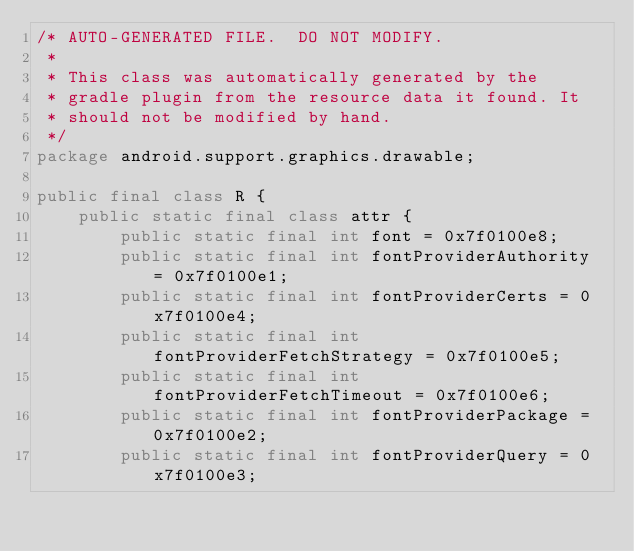<code> <loc_0><loc_0><loc_500><loc_500><_Java_>/* AUTO-GENERATED FILE.  DO NOT MODIFY.
 *
 * This class was automatically generated by the
 * gradle plugin from the resource data it found. It
 * should not be modified by hand.
 */
package android.support.graphics.drawable;

public final class R {
    public static final class attr {
        public static final int font = 0x7f0100e8;
        public static final int fontProviderAuthority = 0x7f0100e1;
        public static final int fontProviderCerts = 0x7f0100e4;
        public static final int fontProviderFetchStrategy = 0x7f0100e5;
        public static final int fontProviderFetchTimeout = 0x7f0100e6;
        public static final int fontProviderPackage = 0x7f0100e2;
        public static final int fontProviderQuery = 0x7f0100e3;</code> 